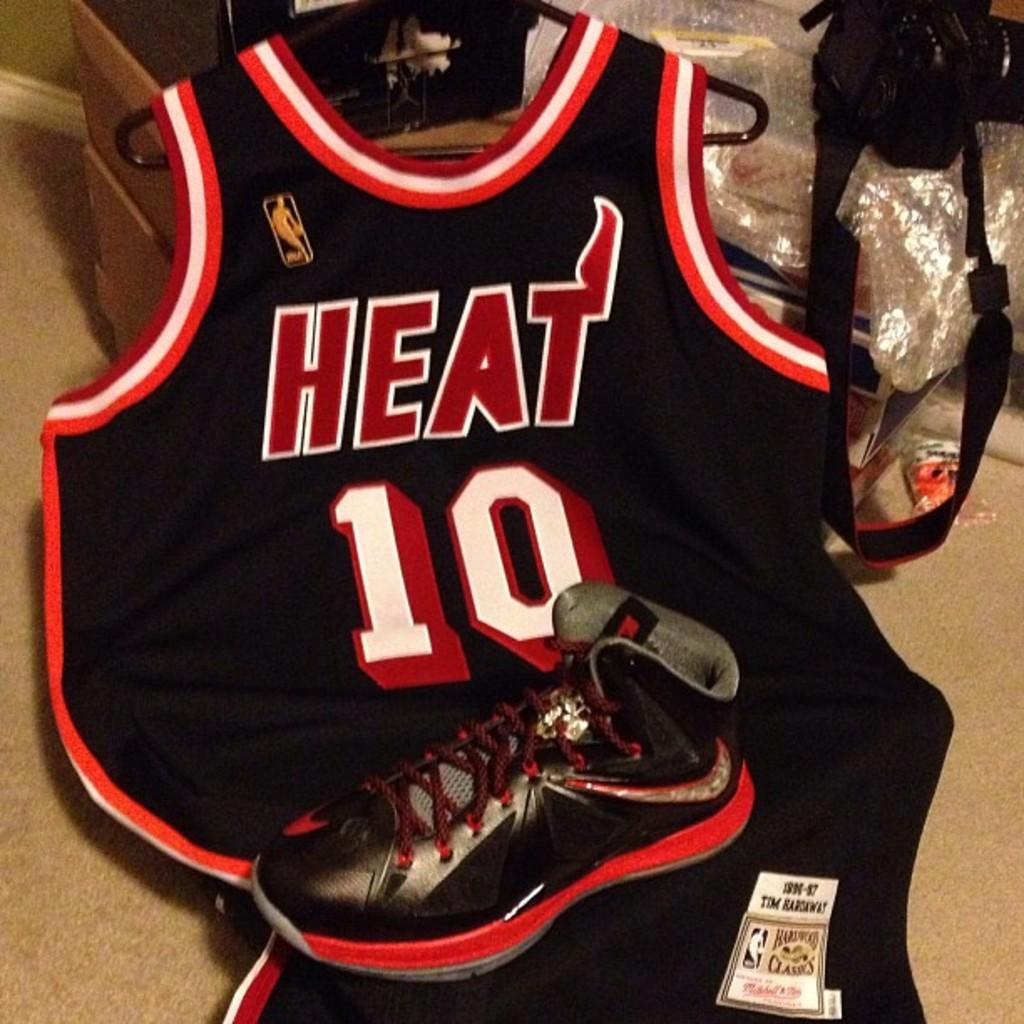<image>
Offer a succinct explanation of the picture presented. A shoe rests on top of a Heat number 10 jersey. 